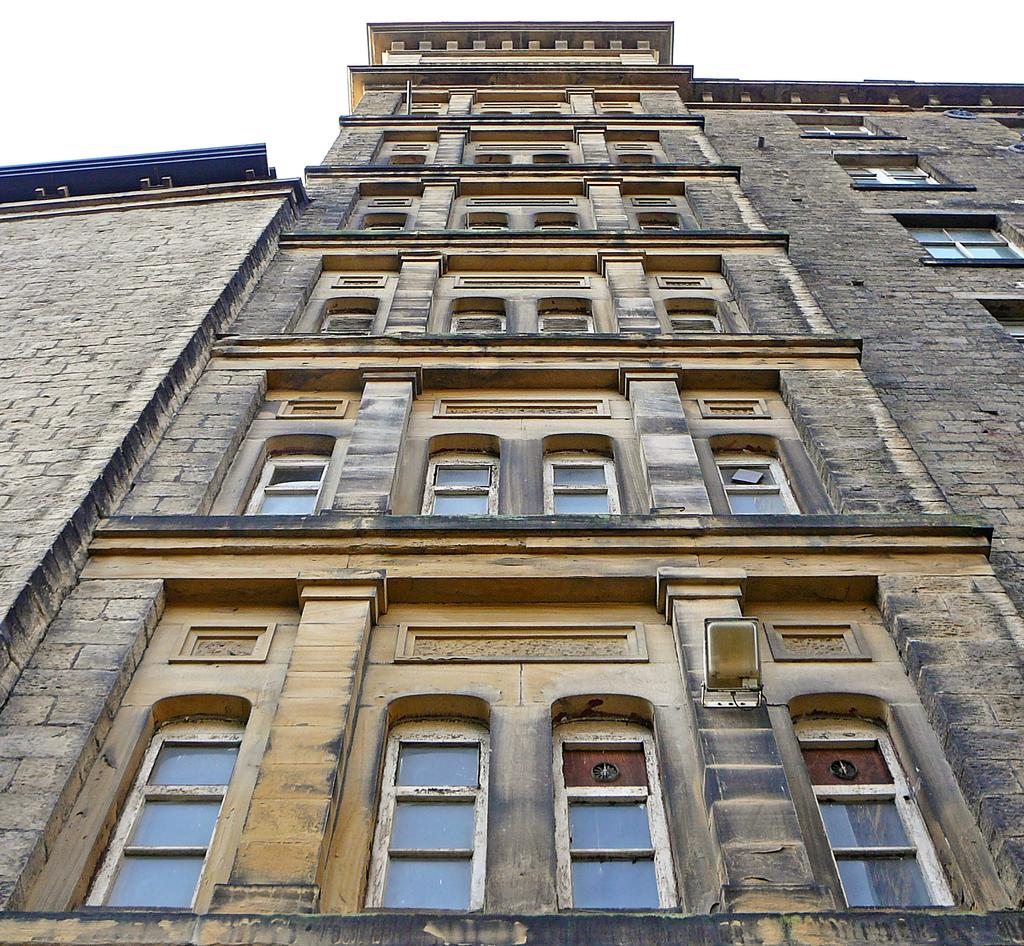What is the main subject of the picture? The main subject of the picture is a building. What specific features can be seen on the building? The building has windows. What can be seen in the background of the picture? The sky is visible in the background of the picture. What type of property is being sold in the image? There is no indication in the image that a property is being sold. How does the brake system work on the building in the image? There is no brake system present in the image, as buildings do not have brake systems. 